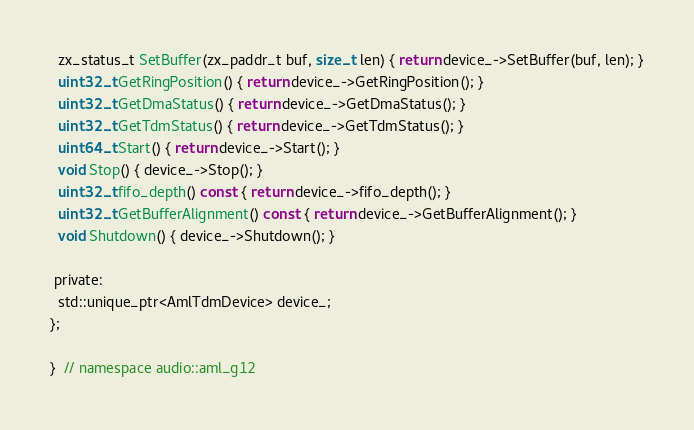<code> <loc_0><loc_0><loc_500><loc_500><_C_>  zx_status_t SetBuffer(zx_paddr_t buf, size_t len) { return device_->SetBuffer(buf, len); }
  uint32_t GetRingPosition() { return device_->GetRingPosition(); }
  uint32_t GetDmaStatus() { return device_->GetDmaStatus(); }
  uint32_t GetTdmStatus() { return device_->GetTdmStatus(); }
  uint64_t Start() { return device_->Start(); }
  void Stop() { device_->Stop(); }
  uint32_t fifo_depth() const { return device_->fifo_depth(); }
  uint32_t GetBufferAlignment() const { return device_->GetBufferAlignment(); }
  void Shutdown() { device_->Shutdown(); }

 private:
  std::unique_ptr<AmlTdmDevice> device_;
};

}  // namespace audio::aml_g12
</code> 